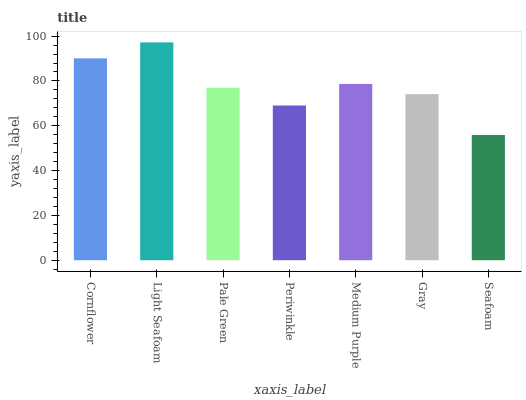Is Seafoam the minimum?
Answer yes or no. Yes. Is Light Seafoam the maximum?
Answer yes or no. Yes. Is Pale Green the minimum?
Answer yes or no. No. Is Pale Green the maximum?
Answer yes or no. No. Is Light Seafoam greater than Pale Green?
Answer yes or no. Yes. Is Pale Green less than Light Seafoam?
Answer yes or no. Yes. Is Pale Green greater than Light Seafoam?
Answer yes or no. No. Is Light Seafoam less than Pale Green?
Answer yes or no. No. Is Pale Green the high median?
Answer yes or no. Yes. Is Pale Green the low median?
Answer yes or no. Yes. Is Light Seafoam the high median?
Answer yes or no. No. Is Light Seafoam the low median?
Answer yes or no. No. 